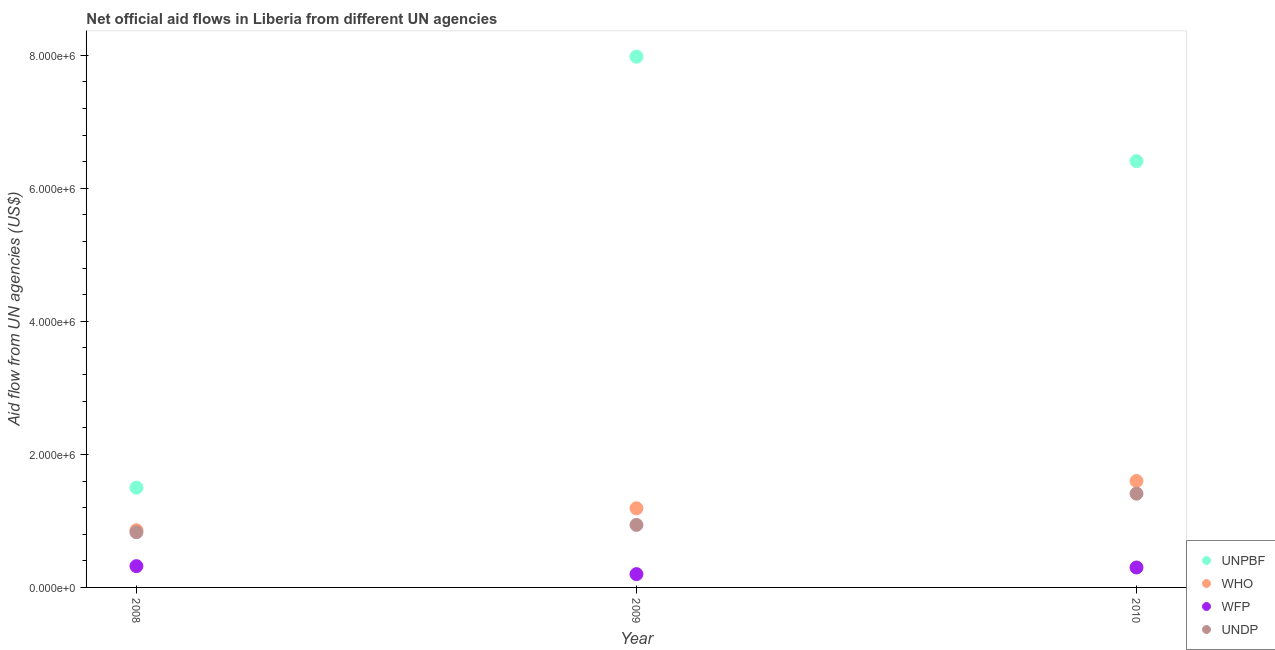How many different coloured dotlines are there?
Your answer should be compact. 4. Is the number of dotlines equal to the number of legend labels?
Your answer should be compact. Yes. What is the amount of aid given by unpbf in 2009?
Provide a succinct answer. 7.98e+06. Across all years, what is the maximum amount of aid given by who?
Your response must be concise. 1.60e+06. Across all years, what is the minimum amount of aid given by who?
Make the answer very short. 8.60e+05. In which year was the amount of aid given by who minimum?
Offer a terse response. 2008. What is the total amount of aid given by undp in the graph?
Your response must be concise. 3.18e+06. What is the difference between the amount of aid given by undp in 2009 and that in 2010?
Provide a short and direct response. -4.70e+05. What is the difference between the amount of aid given by wfp in 2010 and the amount of aid given by undp in 2008?
Ensure brevity in your answer.  -5.30e+05. What is the average amount of aid given by who per year?
Make the answer very short. 1.22e+06. In the year 2010, what is the difference between the amount of aid given by who and amount of aid given by unpbf?
Ensure brevity in your answer.  -4.81e+06. In how many years, is the amount of aid given by who greater than 4400000 US$?
Keep it short and to the point. 0. What is the ratio of the amount of aid given by unpbf in 2008 to that in 2010?
Your answer should be compact. 0.23. Is the difference between the amount of aid given by unpbf in 2008 and 2009 greater than the difference between the amount of aid given by who in 2008 and 2009?
Give a very brief answer. No. What is the difference between the highest and the lowest amount of aid given by wfp?
Your response must be concise. 1.20e+05. In how many years, is the amount of aid given by wfp greater than the average amount of aid given by wfp taken over all years?
Give a very brief answer. 2. Is it the case that in every year, the sum of the amount of aid given by wfp and amount of aid given by unpbf is greater than the sum of amount of aid given by who and amount of aid given by undp?
Your response must be concise. No. Is the amount of aid given by who strictly less than the amount of aid given by undp over the years?
Your answer should be very brief. No. How many years are there in the graph?
Give a very brief answer. 3. What is the difference between two consecutive major ticks on the Y-axis?
Make the answer very short. 2.00e+06. Are the values on the major ticks of Y-axis written in scientific E-notation?
Keep it short and to the point. Yes. Does the graph contain grids?
Give a very brief answer. No. Where does the legend appear in the graph?
Offer a terse response. Bottom right. How are the legend labels stacked?
Make the answer very short. Vertical. What is the title of the graph?
Your answer should be very brief. Net official aid flows in Liberia from different UN agencies. Does "Social Awareness" appear as one of the legend labels in the graph?
Make the answer very short. No. What is the label or title of the X-axis?
Give a very brief answer. Year. What is the label or title of the Y-axis?
Make the answer very short. Aid flow from UN agencies (US$). What is the Aid flow from UN agencies (US$) of UNPBF in 2008?
Your answer should be very brief. 1.50e+06. What is the Aid flow from UN agencies (US$) in WHO in 2008?
Ensure brevity in your answer.  8.60e+05. What is the Aid flow from UN agencies (US$) of WFP in 2008?
Keep it short and to the point. 3.20e+05. What is the Aid flow from UN agencies (US$) in UNDP in 2008?
Give a very brief answer. 8.30e+05. What is the Aid flow from UN agencies (US$) of UNPBF in 2009?
Offer a very short reply. 7.98e+06. What is the Aid flow from UN agencies (US$) of WHO in 2009?
Provide a short and direct response. 1.19e+06. What is the Aid flow from UN agencies (US$) in UNDP in 2009?
Ensure brevity in your answer.  9.40e+05. What is the Aid flow from UN agencies (US$) in UNPBF in 2010?
Make the answer very short. 6.41e+06. What is the Aid flow from UN agencies (US$) of WHO in 2010?
Your answer should be very brief. 1.60e+06. What is the Aid flow from UN agencies (US$) of WFP in 2010?
Your response must be concise. 3.00e+05. What is the Aid flow from UN agencies (US$) in UNDP in 2010?
Make the answer very short. 1.41e+06. Across all years, what is the maximum Aid flow from UN agencies (US$) in UNPBF?
Provide a short and direct response. 7.98e+06. Across all years, what is the maximum Aid flow from UN agencies (US$) in WHO?
Provide a short and direct response. 1.60e+06. Across all years, what is the maximum Aid flow from UN agencies (US$) of UNDP?
Provide a short and direct response. 1.41e+06. Across all years, what is the minimum Aid flow from UN agencies (US$) in UNPBF?
Keep it short and to the point. 1.50e+06. Across all years, what is the minimum Aid flow from UN agencies (US$) of WHO?
Give a very brief answer. 8.60e+05. Across all years, what is the minimum Aid flow from UN agencies (US$) of UNDP?
Offer a terse response. 8.30e+05. What is the total Aid flow from UN agencies (US$) in UNPBF in the graph?
Your answer should be very brief. 1.59e+07. What is the total Aid flow from UN agencies (US$) of WHO in the graph?
Offer a terse response. 3.65e+06. What is the total Aid flow from UN agencies (US$) in WFP in the graph?
Give a very brief answer. 8.20e+05. What is the total Aid flow from UN agencies (US$) of UNDP in the graph?
Offer a terse response. 3.18e+06. What is the difference between the Aid flow from UN agencies (US$) of UNPBF in 2008 and that in 2009?
Ensure brevity in your answer.  -6.48e+06. What is the difference between the Aid flow from UN agencies (US$) in WHO in 2008 and that in 2009?
Your response must be concise. -3.30e+05. What is the difference between the Aid flow from UN agencies (US$) of UNPBF in 2008 and that in 2010?
Ensure brevity in your answer.  -4.91e+06. What is the difference between the Aid flow from UN agencies (US$) in WHO in 2008 and that in 2010?
Ensure brevity in your answer.  -7.40e+05. What is the difference between the Aid flow from UN agencies (US$) of WFP in 2008 and that in 2010?
Offer a very short reply. 2.00e+04. What is the difference between the Aid flow from UN agencies (US$) of UNDP in 2008 and that in 2010?
Offer a terse response. -5.80e+05. What is the difference between the Aid flow from UN agencies (US$) of UNPBF in 2009 and that in 2010?
Offer a very short reply. 1.57e+06. What is the difference between the Aid flow from UN agencies (US$) in WHO in 2009 and that in 2010?
Offer a very short reply. -4.10e+05. What is the difference between the Aid flow from UN agencies (US$) in WFP in 2009 and that in 2010?
Offer a very short reply. -1.00e+05. What is the difference between the Aid flow from UN agencies (US$) in UNDP in 2009 and that in 2010?
Your answer should be very brief. -4.70e+05. What is the difference between the Aid flow from UN agencies (US$) in UNPBF in 2008 and the Aid flow from UN agencies (US$) in WHO in 2009?
Your answer should be very brief. 3.10e+05. What is the difference between the Aid flow from UN agencies (US$) in UNPBF in 2008 and the Aid flow from UN agencies (US$) in WFP in 2009?
Give a very brief answer. 1.30e+06. What is the difference between the Aid flow from UN agencies (US$) of UNPBF in 2008 and the Aid flow from UN agencies (US$) of UNDP in 2009?
Offer a terse response. 5.60e+05. What is the difference between the Aid flow from UN agencies (US$) of WHO in 2008 and the Aid flow from UN agencies (US$) of WFP in 2009?
Offer a terse response. 6.60e+05. What is the difference between the Aid flow from UN agencies (US$) in WFP in 2008 and the Aid flow from UN agencies (US$) in UNDP in 2009?
Provide a succinct answer. -6.20e+05. What is the difference between the Aid flow from UN agencies (US$) in UNPBF in 2008 and the Aid flow from UN agencies (US$) in WFP in 2010?
Offer a terse response. 1.20e+06. What is the difference between the Aid flow from UN agencies (US$) of WHO in 2008 and the Aid flow from UN agencies (US$) of WFP in 2010?
Keep it short and to the point. 5.60e+05. What is the difference between the Aid flow from UN agencies (US$) in WHO in 2008 and the Aid flow from UN agencies (US$) in UNDP in 2010?
Your response must be concise. -5.50e+05. What is the difference between the Aid flow from UN agencies (US$) of WFP in 2008 and the Aid flow from UN agencies (US$) of UNDP in 2010?
Your answer should be very brief. -1.09e+06. What is the difference between the Aid flow from UN agencies (US$) in UNPBF in 2009 and the Aid flow from UN agencies (US$) in WHO in 2010?
Offer a terse response. 6.38e+06. What is the difference between the Aid flow from UN agencies (US$) in UNPBF in 2009 and the Aid flow from UN agencies (US$) in WFP in 2010?
Provide a succinct answer. 7.68e+06. What is the difference between the Aid flow from UN agencies (US$) of UNPBF in 2009 and the Aid flow from UN agencies (US$) of UNDP in 2010?
Your response must be concise. 6.57e+06. What is the difference between the Aid flow from UN agencies (US$) in WHO in 2009 and the Aid flow from UN agencies (US$) in WFP in 2010?
Offer a terse response. 8.90e+05. What is the difference between the Aid flow from UN agencies (US$) in WFP in 2009 and the Aid flow from UN agencies (US$) in UNDP in 2010?
Offer a very short reply. -1.21e+06. What is the average Aid flow from UN agencies (US$) in UNPBF per year?
Your response must be concise. 5.30e+06. What is the average Aid flow from UN agencies (US$) in WHO per year?
Offer a terse response. 1.22e+06. What is the average Aid flow from UN agencies (US$) in WFP per year?
Provide a succinct answer. 2.73e+05. What is the average Aid flow from UN agencies (US$) in UNDP per year?
Keep it short and to the point. 1.06e+06. In the year 2008, what is the difference between the Aid flow from UN agencies (US$) of UNPBF and Aid flow from UN agencies (US$) of WHO?
Your answer should be compact. 6.40e+05. In the year 2008, what is the difference between the Aid flow from UN agencies (US$) of UNPBF and Aid flow from UN agencies (US$) of WFP?
Provide a short and direct response. 1.18e+06. In the year 2008, what is the difference between the Aid flow from UN agencies (US$) in UNPBF and Aid flow from UN agencies (US$) in UNDP?
Offer a very short reply. 6.70e+05. In the year 2008, what is the difference between the Aid flow from UN agencies (US$) of WHO and Aid flow from UN agencies (US$) of WFP?
Make the answer very short. 5.40e+05. In the year 2008, what is the difference between the Aid flow from UN agencies (US$) of WFP and Aid flow from UN agencies (US$) of UNDP?
Offer a terse response. -5.10e+05. In the year 2009, what is the difference between the Aid flow from UN agencies (US$) in UNPBF and Aid flow from UN agencies (US$) in WHO?
Ensure brevity in your answer.  6.79e+06. In the year 2009, what is the difference between the Aid flow from UN agencies (US$) of UNPBF and Aid flow from UN agencies (US$) of WFP?
Ensure brevity in your answer.  7.78e+06. In the year 2009, what is the difference between the Aid flow from UN agencies (US$) in UNPBF and Aid flow from UN agencies (US$) in UNDP?
Offer a terse response. 7.04e+06. In the year 2009, what is the difference between the Aid flow from UN agencies (US$) of WHO and Aid flow from UN agencies (US$) of WFP?
Make the answer very short. 9.90e+05. In the year 2009, what is the difference between the Aid flow from UN agencies (US$) of WFP and Aid flow from UN agencies (US$) of UNDP?
Your answer should be compact. -7.40e+05. In the year 2010, what is the difference between the Aid flow from UN agencies (US$) in UNPBF and Aid flow from UN agencies (US$) in WHO?
Your response must be concise. 4.81e+06. In the year 2010, what is the difference between the Aid flow from UN agencies (US$) of UNPBF and Aid flow from UN agencies (US$) of WFP?
Give a very brief answer. 6.11e+06. In the year 2010, what is the difference between the Aid flow from UN agencies (US$) of UNPBF and Aid flow from UN agencies (US$) of UNDP?
Your answer should be very brief. 5.00e+06. In the year 2010, what is the difference between the Aid flow from UN agencies (US$) of WHO and Aid flow from UN agencies (US$) of WFP?
Your response must be concise. 1.30e+06. In the year 2010, what is the difference between the Aid flow from UN agencies (US$) in WHO and Aid flow from UN agencies (US$) in UNDP?
Give a very brief answer. 1.90e+05. In the year 2010, what is the difference between the Aid flow from UN agencies (US$) of WFP and Aid flow from UN agencies (US$) of UNDP?
Offer a very short reply. -1.11e+06. What is the ratio of the Aid flow from UN agencies (US$) of UNPBF in 2008 to that in 2009?
Provide a short and direct response. 0.19. What is the ratio of the Aid flow from UN agencies (US$) of WHO in 2008 to that in 2009?
Your answer should be very brief. 0.72. What is the ratio of the Aid flow from UN agencies (US$) of WFP in 2008 to that in 2009?
Keep it short and to the point. 1.6. What is the ratio of the Aid flow from UN agencies (US$) of UNDP in 2008 to that in 2009?
Offer a terse response. 0.88. What is the ratio of the Aid flow from UN agencies (US$) of UNPBF in 2008 to that in 2010?
Offer a terse response. 0.23. What is the ratio of the Aid flow from UN agencies (US$) of WHO in 2008 to that in 2010?
Offer a very short reply. 0.54. What is the ratio of the Aid flow from UN agencies (US$) in WFP in 2008 to that in 2010?
Your answer should be very brief. 1.07. What is the ratio of the Aid flow from UN agencies (US$) in UNDP in 2008 to that in 2010?
Offer a terse response. 0.59. What is the ratio of the Aid flow from UN agencies (US$) of UNPBF in 2009 to that in 2010?
Offer a very short reply. 1.24. What is the ratio of the Aid flow from UN agencies (US$) of WHO in 2009 to that in 2010?
Offer a terse response. 0.74. What is the ratio of the Aid flow from UN agencies (US$) of WFP in 2009 to that in 2010?
Offer a terse response. 0.67. What is the difference between the highest and the second highest Aid flow from UN agencies (US$) in UNPBF?
Your answer should be compact. 1.57e+06. What is the difference between the highest and the second highest Aid flow from UN agencies (US$) in UNDP?
Ensure brevity in your answer.  4.70e+05. What is the difference between the highest and the lowest Aid flow from UN agencies (US$) in UNPBF?
Keep it short and to the point. 6.48e+06. What is the difference between the highest and the lowest Aid flow from UN agencies (US$) of WHO?
Provide a succinct answer. 7.40e+05. What is the difference between the highest and the lowest Aid flow from UN agencies (US$) in UNDP?
Your answer should be compact. 5.80e+05. 